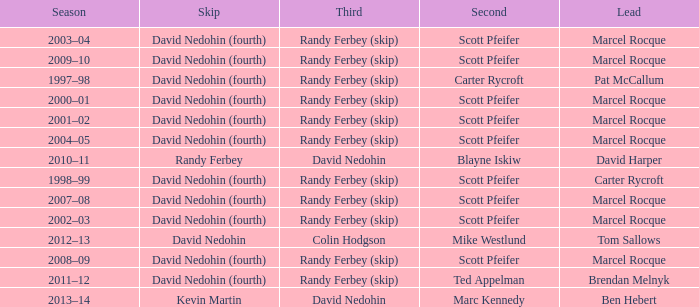Which Season has a Third of colin hodgson? 2012–13. 